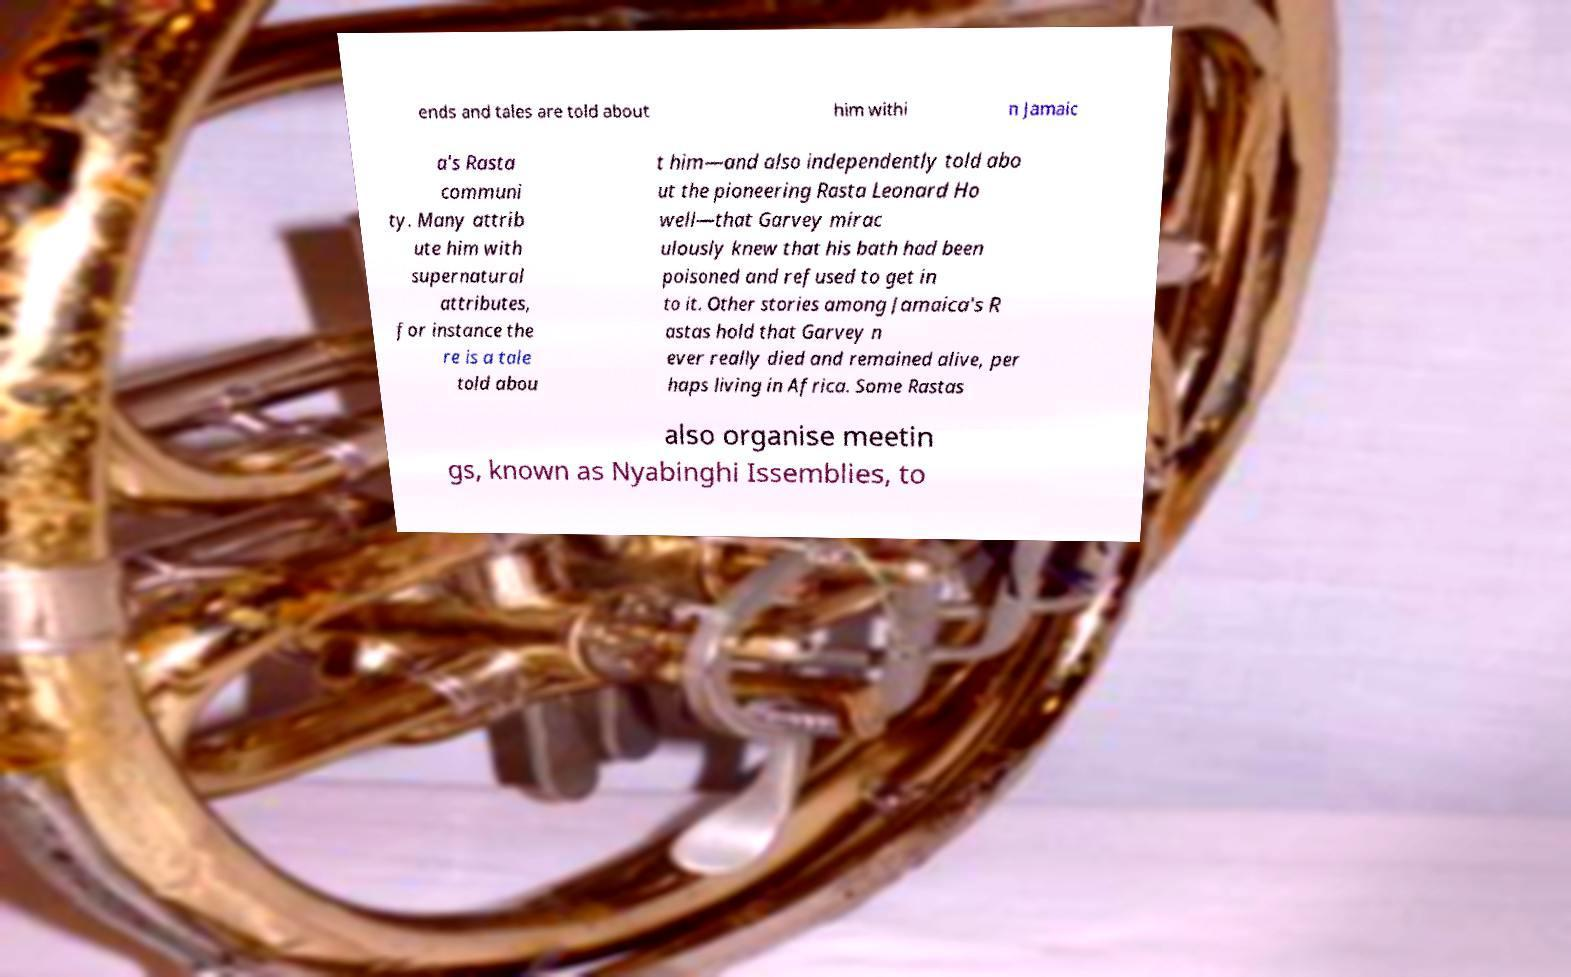Could you extract and type out the text from this image? ends and tales are told about him withi n Jamaic a's Rasta communi ty. Many attrib ute him with supernatural attributes, for instance the re is a tale told abou t him—and also independently told abo ut the pioneering Rasta Leonard Ho well—that Garvey mirac ulously knew that his bath had been poisoned and refused to get in to it. Other stories among Jamaica's R astas hold that Garvey n ever really died and remained alive, per haps living in Africa. Some Rastas also organise meetin gs, known as Nyabinghi Issemblies, to 